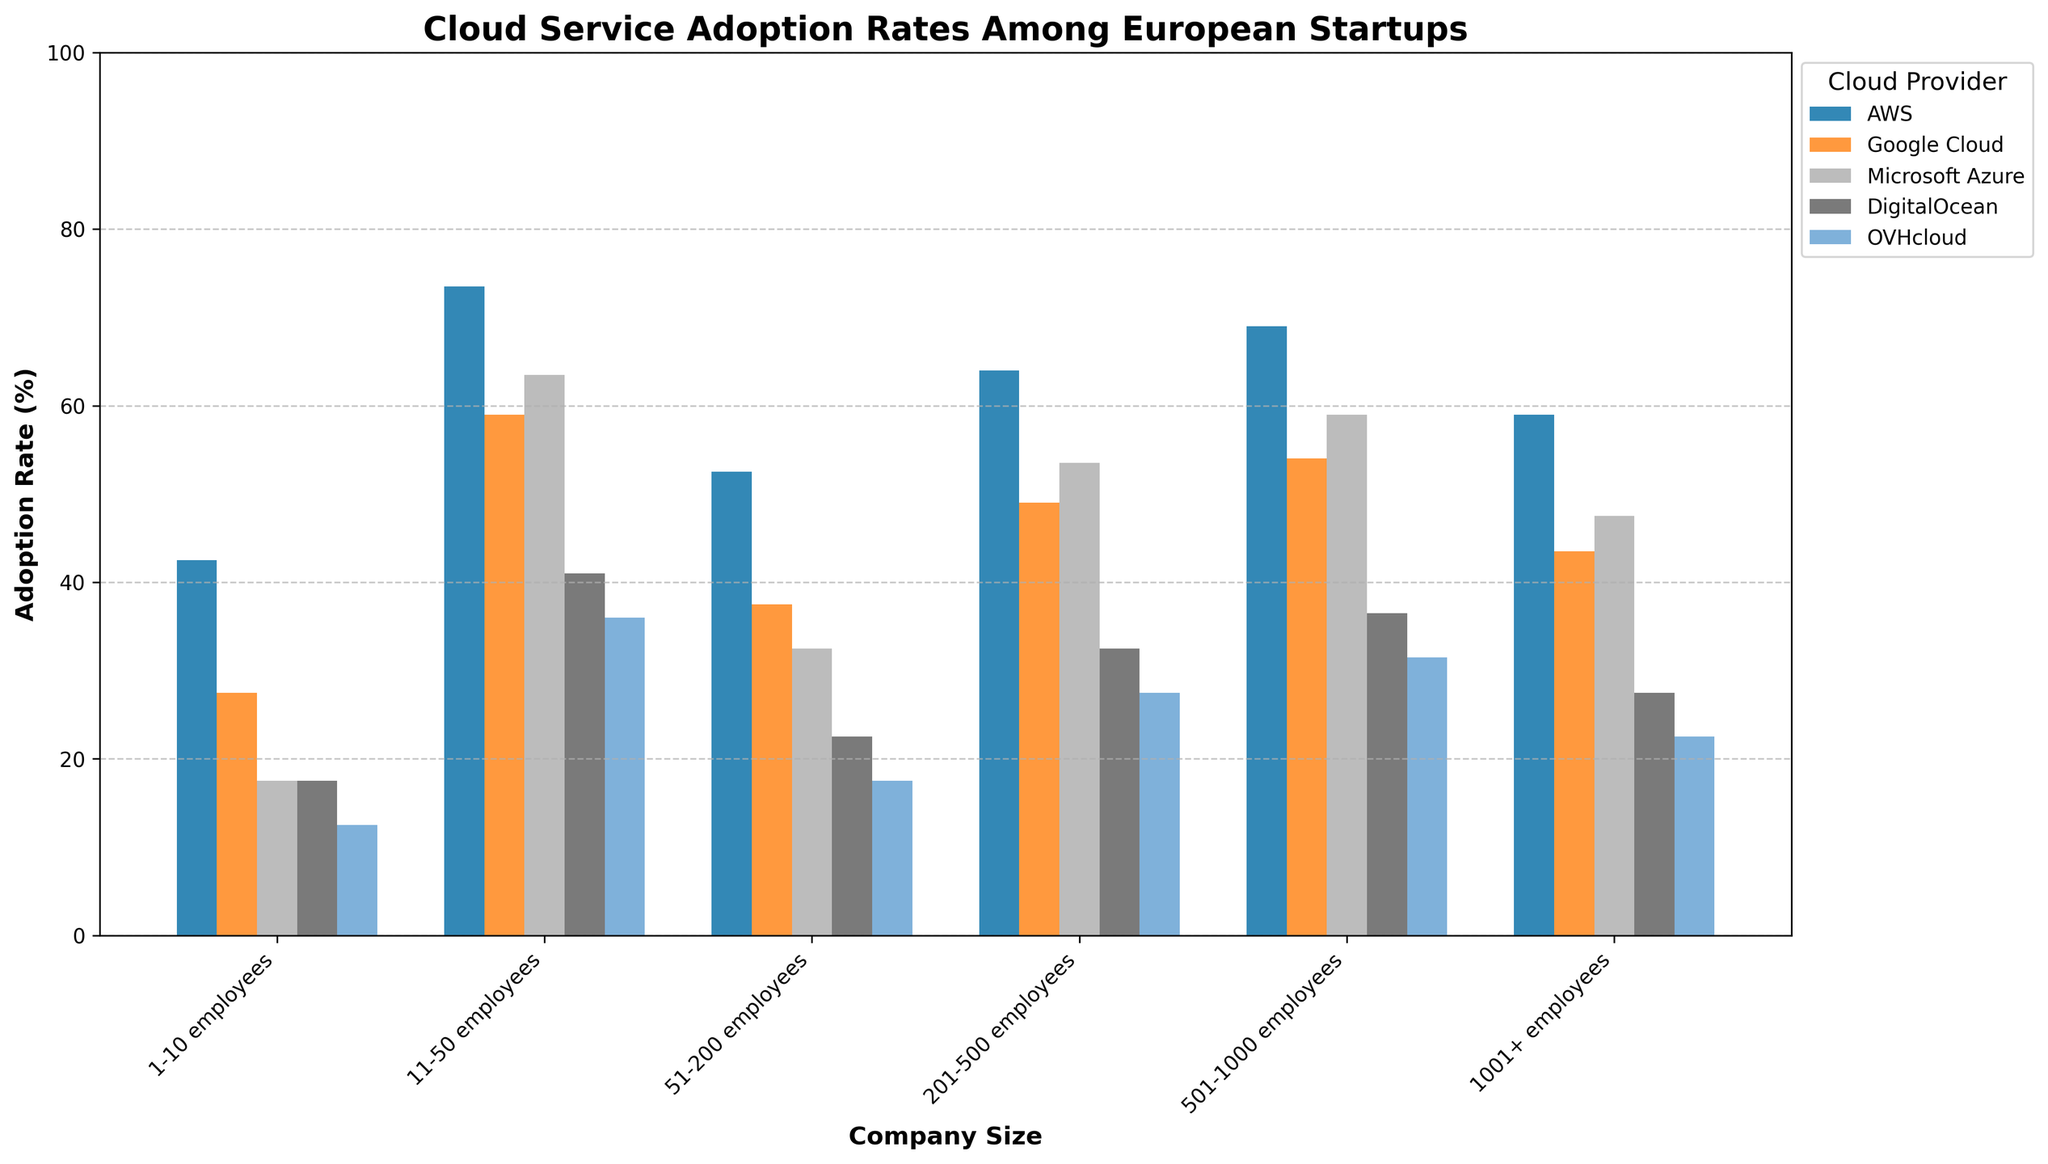What is the adoption rate of AWS among companies with 501-1000 employees? In the figure, look for the bar representing AWS adoption for the "501-1000 employees" category, note the height value.
Answer: 70% Which cloud provider has the lowest adoption rate among companies in the Seed funding stage? In the Seed funding stage group, compare the bars representing different cloud providers and identify the lowest bar height.
Answer: OVHcloud By how much does AWS adoption rate increase from companies in the Seed stage to the Series C stage? Locate the AWS adoption rates for Seed and Series C stages, then compute the difference: Seed (45%) and Series C (65%).
Answer: 20% What is the sum of adoption rates for all cloud providers in the IPO/Late Stage? Add the adoption rates for AWS (75%), Google Cloud (60%), Microsoft Azure (65%), DigitalOcean (40%), and OVHcloud (35%) for IPO/Late Stage.
Answer: 275% Which company size category shows the highest adoption rate for Microsoft Azure? Compare the heights of all the bars representing Microsoft Azure across different company size categories and find the tallest bar.
Answer: 1001+ employees Are there any cloud providers whose adoption rate decreases as the company size increases? Observe the trend of bars for each cloud provider across increasing company sizes to see if any provider’s bar heights decrease.
Answer: No What is the average adoption rate of DigitalOcean for companies with 1-10 employees across all funding stages? Find the DigitalOcean adoption rates for 1-10 employees (Seed and Bootstrapped), then calculate the average: (15 + 20)/2.
Answer: 17.5% How does Google Cloud adoption in companies with 51-200 employees vary from Series A to Series B stages? Compare the Google Cloud adoption rates for 51-200 employees in Series A (42%) and Series B (48%), then determine the difference.
Answer: 6% Which cloud provider has the most uniform adoption rate across all company sizes? Visually compare the consistency in bar heights for each cloud provider across all company sizes.
Answer: AWS 